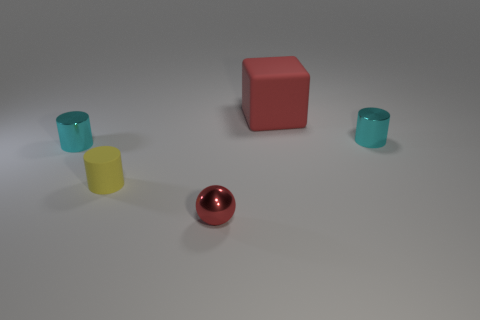Subtract all matte cylinders. How many cylinders are left? 2 Subtract 1 cubes. How many cubes are left? 0 Subtract 0 red cylinders. How many objects are left? 5 Subtract all blocks. How many objects are left? 4 Subtract all brown cylinders. Subtract all blue spheres. How many cylinders are left? 3 Subtract all yellow cylinders. How many blue blocks are left? 0 Subtract all big red shiny cubes. Subtract all large matte things. How many objects are left? 4 Add 5 tiny shiny spheres. How many tiny shiny spheres are left? 6 Add 3 red spheres. How many red spheres exist? 4 Add 2 yellow metal cylinders. How many objects exist? 7 